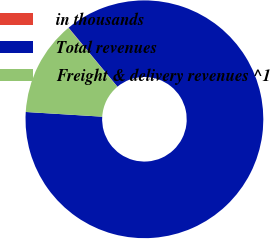Convert chart to OTSL. <chart><loc_0><loc_0><loc_500><loc_500><pie_chart><fcel>in thousands<fcel>Total revenues<fcel>Freight & delivery revenues ^1<nl><fcel>0.05%<fcel>86.98%<fcel>12.97%<nl></chart> 